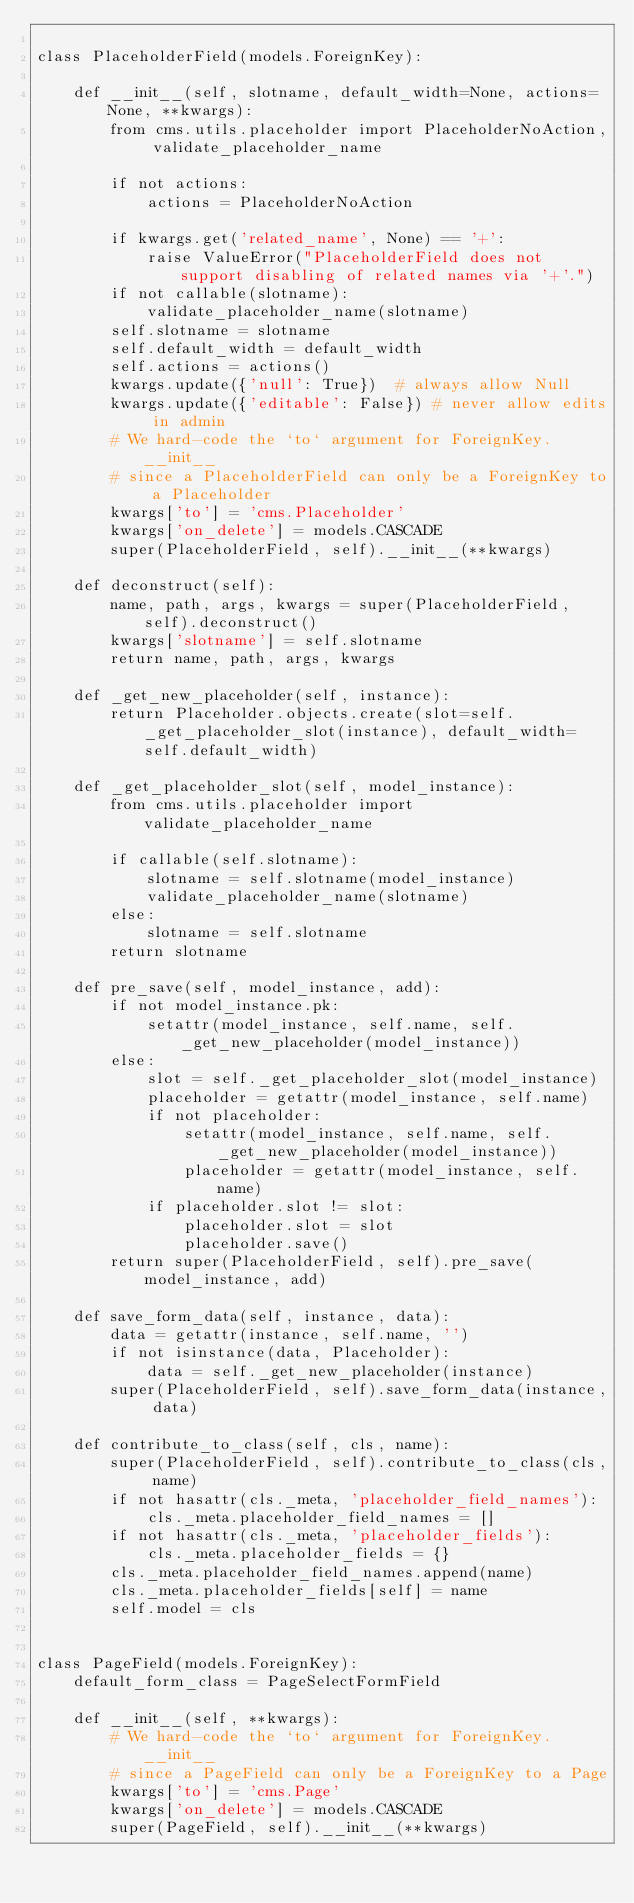<code> <loc_0><loc_0><loc_500><loc_500><_Python_>
class PlaceholderField(models.ForeignKey):

    def __init__(self, slotname, default_width=None, actions=None, **kwargs):
        from cms.utils.placeholder import PlaceholderNoAction, validate_placeholder_name

        if not actions:
            actions = PlaceholderNoAction

        if kwargs.get('related_name', None) == '+':
            raise ValueError("PlaceholderField does not support disabling of related names via '+'.")
        if not callable(slotname):
            validate_placeholder_name(slotname)
        self.slotname = slotname
        self.default_width = default_width
        self.actions = actions()
        kwargs.update({'null': True})  # always allow Null
        kwargs.update({'editable': False}) # never allow edits in admin
        # We hard-code the `to` argument for ForeignKey.__init__
        # since a PlaceholderField can only be a ForeignKey to a Placeholder
        kwargs['to'] = 'cms.Placeholder'
        kwargs['on_delete'] = models.CASCADE
        super(PlaceholderField, self).__init__(**kwargs)

    def deconstruct(self):
        name, path, args, kwargs = super(PlaceholderField, self).deconstruct()
        kwargs['slotname'] = self.slotname
        return name, path, args, kwargs

    def _get_new_placeholder(self, instance):
        return Placeholder.objects.create(slot=self._get_placeholder_slot(instance), default_width=self.default_width)

    def _get_placeholder_slot(self, model_instance):
        from cms.utils.placeholder import validate_placeholder_name

        if callable(self.slotname):
            slotname = self.slotname(model_instance)
            validate_placeholder_name(slotname)
        else:
            slotname = self.slotname
        return slotname

    def pre_save(self, model_instance, add):
        if not model_instance.pk:
            setattr(model_instance, self.name, self._get_new_placeholder(model_instance))
        else:
            slot = self._get_placeholder_slot(model_instance)
            placeholder = getattr(model_instance, self.name)
            if not placeholder:
                setattr(model_instance, self.name, self._get_new_placeholder(model_instance))
                placeholder = getattr(model_instance, self.name)
            if placeholder.slot != slot:
                placeholder.slot = slot
                placeholder.save()
        return super(PlaceholderField, self).pre_save(model_instance, add)

    def save_form_data(self, instance, data):
        data = getattr(instance, self.name, '')
        if not isinstance(data, Placeholder):
            data = self._get_new_placeholder(instance)
        super(PlaceholderField, self).save_form_data(instance, data)

    def contribute_to_class(self, cls, name):
        super(PlaceholderField, self).contribute_to_class(cls, name)
        if not hasattr(cls._meta, 'placeholder_field_names'):
            cls._meta.placeholder_field_names = []
        if not hasattr(cls._meta, 'placeholder_fields'):
            cls._meta.placeholder_fields = {}
        cls._meta.placeholder_field_names.append(name)
        cls._meta.placeholder_fields[self] = name
        self.model = cls


class PageField(models.ForeignKey):
    default_form_class = PageSelectFormField

    def __init__(self, **kwargs):
        # We hard-code the `to` argument for ForeignKey.__init__
        # since a PageField can only be a ForeignKey to a Page
        kwargs['to'] = 'cms.Page'
        kwargs['on_delete'] = models.CASCADE
        super(PageField, self).__init__(**kwargs)
</code> 